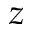Convert formula to latex. <formula><loc_0><loc_0><loc_500><loc_500>z</formula> 